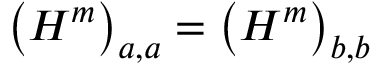Convert formula to latex. <formula><loc_0><loc_0><loc_500><loc_500>\left ( H ^ { m } \right ) _ { a , a } = \left ( H ^ { m } \right ) _ { b , b }</formula> 